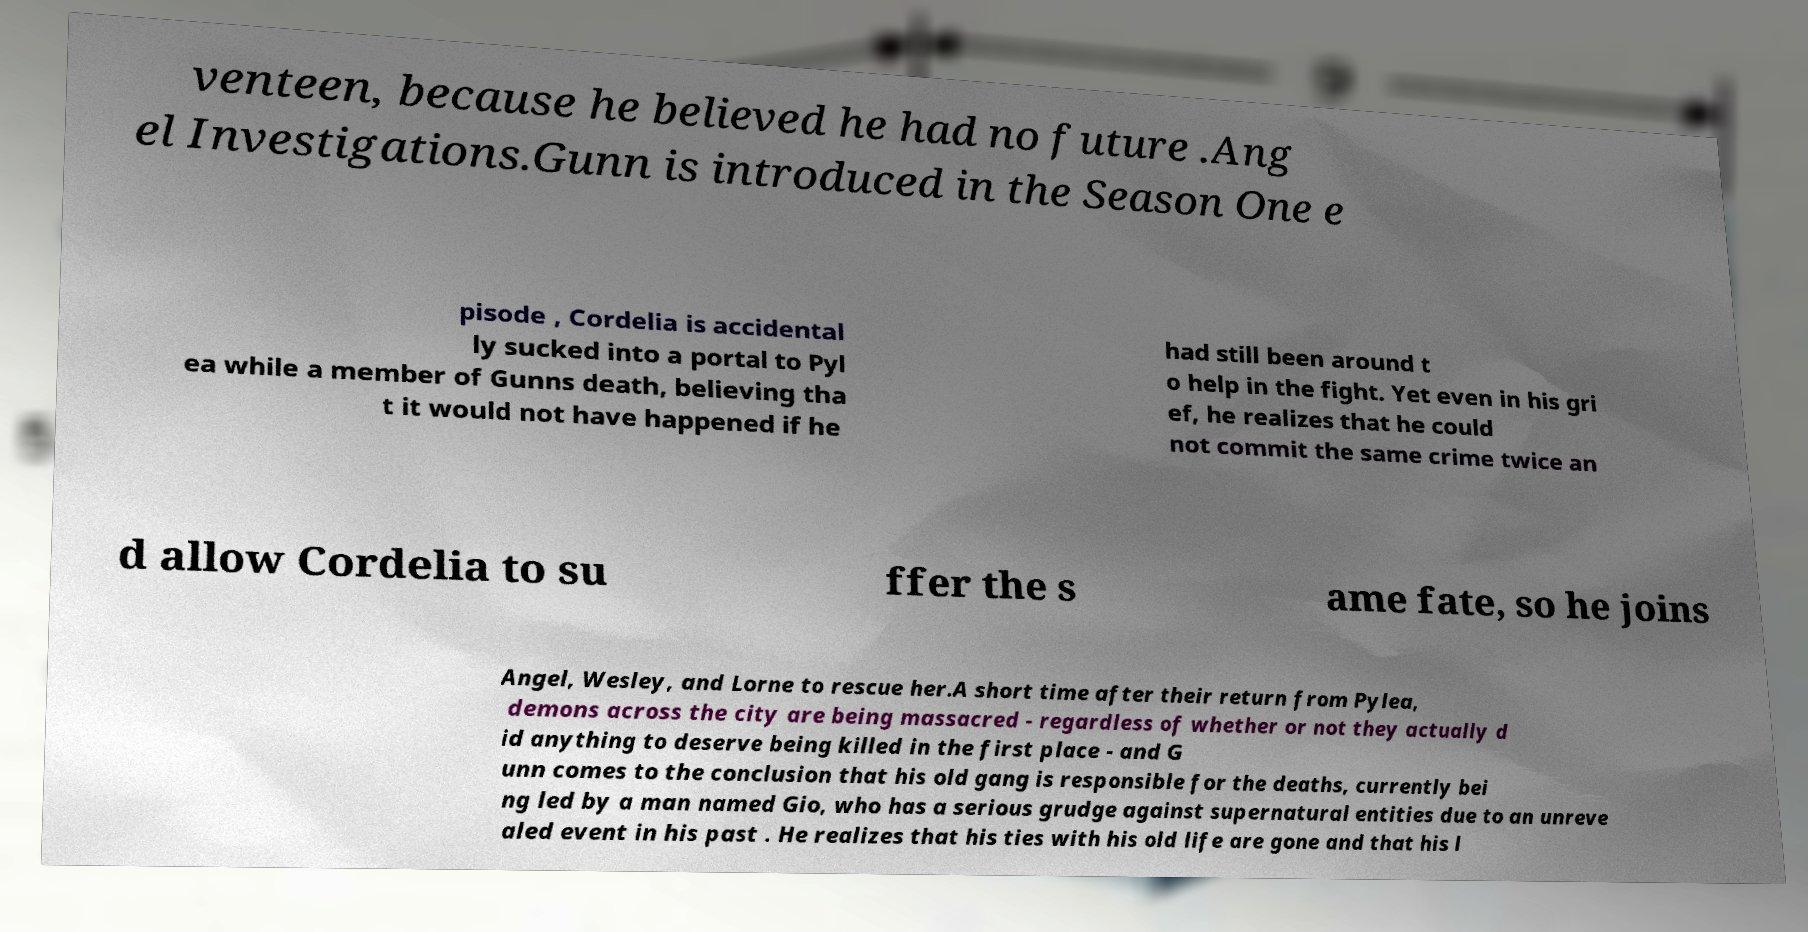For documentation purposes, I need the text within this image transcribed. Could you provide that? venteen, because he believed he had no future .Ang el Investigations.Gunn is introduced in the Season One e pisode , Cordelia is accidental ly sucked into a portal to Pyl ea while a member of Gunns death, believing tha t it would not have happened if he had still been around t o help in the fight. Yet even in his gri ef, he realizes that he could not commit the same crime twice an d allow Cordelia to su ffer the s ame fate, so he joins Angel, Wesley, and Lorne to rescue her.A short time after their return from Pylea, demons across the city are being massacred - regardless of whether or not they actually d id anything to deserve being killed in the first place - and G unn comes to the conclusion that his old gang is responsible for the deaths, currently bei ng led by a man named Gio, who has a serious grudge against supernatural entities due to an unreve aled event in his past . He realizes that his ties with his old life are gone and that his l 